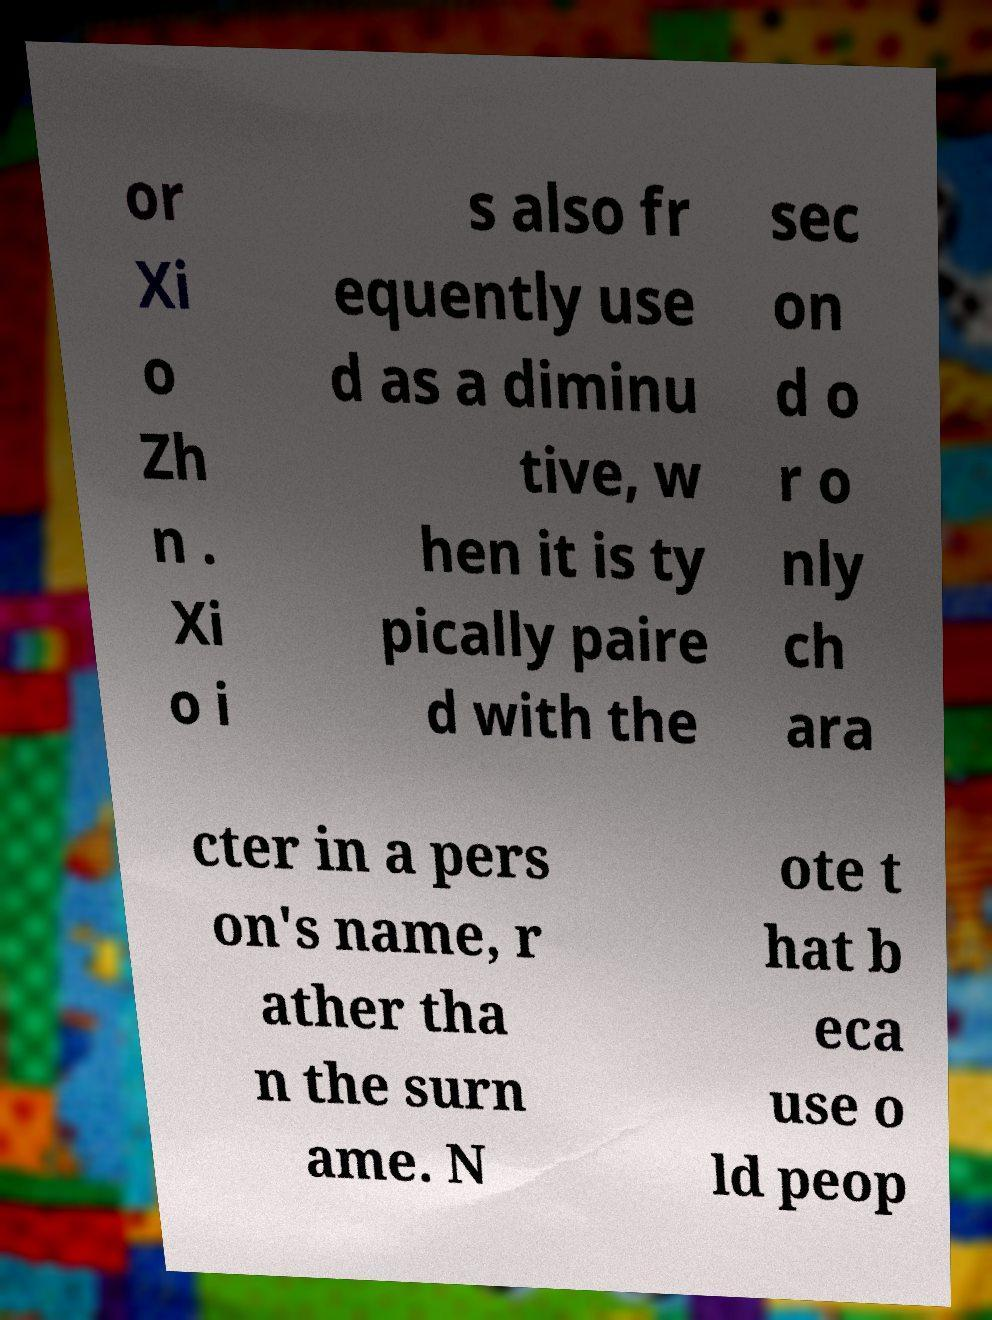Could you extract and type out the text from this image? or Xi o Zh n . Xi o i s also fr equently use d as a diminu tive, w hen it is ty pically paire d with the sec on d o r o nly ch ara cter in a pers on's name, r ather tha n the surn ame. N ote t hat b eca use o ld peop 